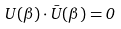<formula> <loc_0><loc_0><loc_500><loc_500>U ( \beta ) \cdot \bar { U } ( \beta ) = 0</formula> 